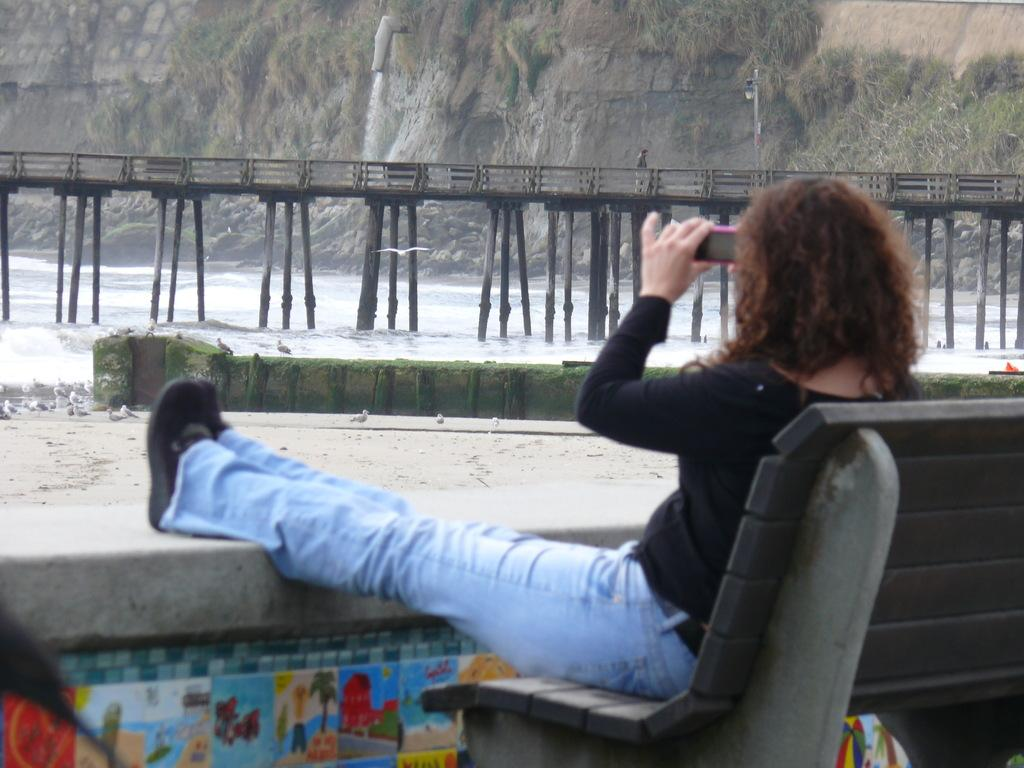What is the woman in the image doing? The woman is sitting on a bench in the image. What is the woman holding in the image? The woman is holding a mobile in the image. What natural feature is located in front of the bench? There is: There is a waterfall in front of the bench in the image. What type of terrain is visible near the waterfall? Rocks are present near the waterfall in the image. What type of vegetation can be seen in the image? There are trees visible in the image. What type of fog can be seen surrounding the woman in the image? There is no fog present in the image; it is clear and shows the woman sitting on a bench, a waterfall, rocks, and trees. 